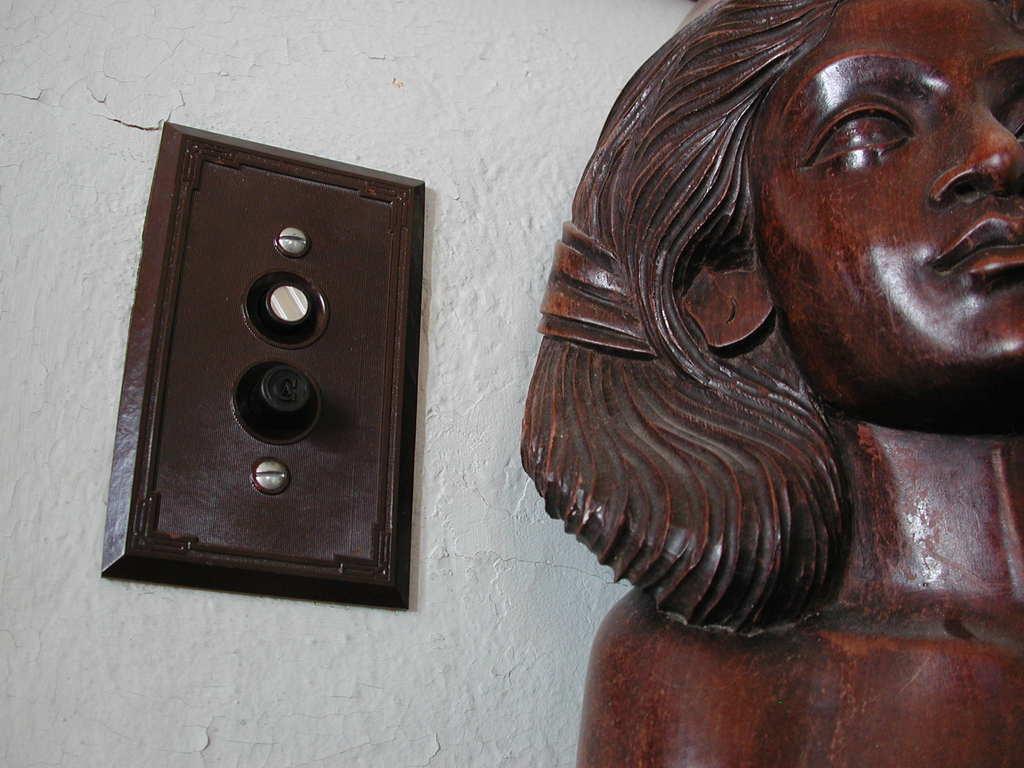Please provide a concise description of this image. In the foreground of this picture, there is a sculpture on the right and a brown board to the wall. 